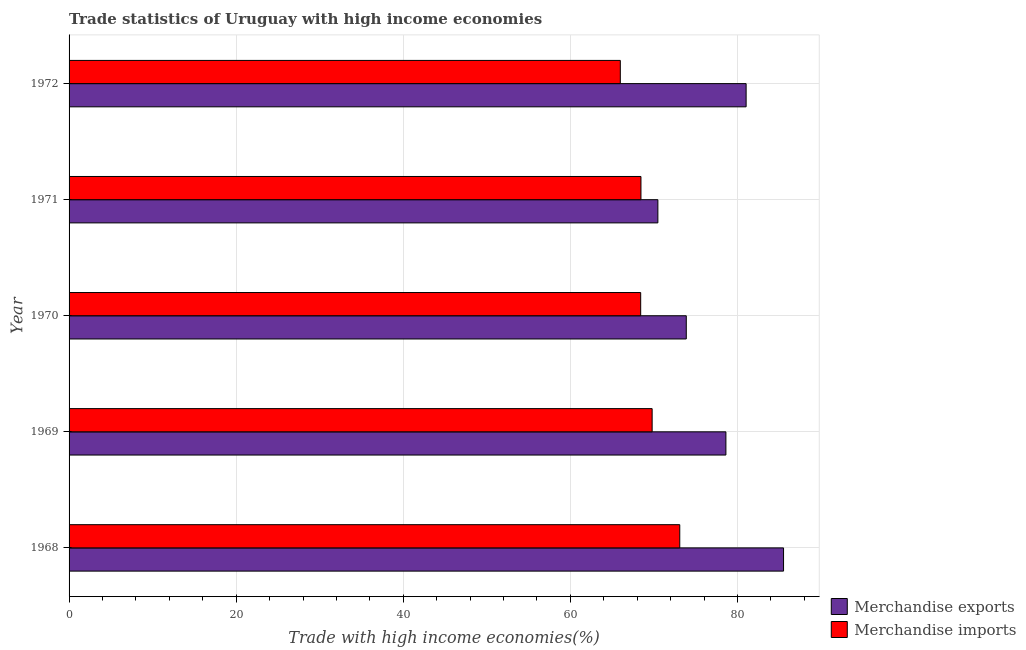How many different coloured bars are there?
Keep it short and to the point. 2. How many bars are there on the 4th tick from the top?
Your answer should be very brief. 2. In how many cases, is the number of bars for a given year not equal to the number of legend labels?
Provide a short and direct response. 0. What is the merchandise imports in 1968?
Provide a short and direct response. 73.09. Across all years, what is the maximum merchandise imports?
Offer a very short reply. 73.09. Across all years, what is the minimum merchandise exports?
Give a very brief answer. 70.47. In which year was the merchandise imports maximum?
Give a very brief answer. 1968. In which year was the merchandise imports minimum?
Your answer should be compact. 1972. What is the total merchandise imports in the graph?
Give a very brief answer. 345.71. What is the difference between the merchandise exports in 1971 and that in 1972?
Your answer should be compact. -10.56. What is the difference between the merchandise imports in 1971 and the merchandise exports in 1970?
Offer a very short reply. -5.42. What is the average merchandise imports per year?
Offer a very short reply. 69.14. In the year 1969, what is the difference between the merchandise exports and merchandise imports?
Make the answer very short. 8.83. What is the ratio of the merchandise imports in 1969 to that in 1971?
Keep it short and to the point. 1.02. Is the difference between the merchandise imports in 1968 and 1969 greater than the difference between the merchandise exports in 1968 and 1969?
Your answer should be very brief. No. What is the difference between the highest and the second highest merchandise exports?
Keep it short and to the point. 4.48. What is the difference between the highest and the lowest merchandise exports?
Offer a terse response. 15.04. What does the 1st bar from the top in 1969 represents?
Give a very brief answer. Merchandise imports. What does the 2nd bar from the bottom in 1968 represents?
Keep it short and to the point. Merchandise imports. How many bars are there?
Keep it short and to the point. 10. Are all the bars in the graph horizontal?
Ensure brevity in your answer.  Yes. What is the difference between two consecutive major ticks on the X-axis?
Offer a terse response. 20. Are the values on the major ticks of X-axis written in scientific E-notation?
Give a very brief answer. No. What is the title of the graph?
Ensure brevity in your answer.  Trade statistics of Uruguay with high income economies. What is the label or title of the X-axis?
Your answer should be compact. Trade with high income economies(%). What is the label or title of the Y-axis?
Give a very brief answer. Year. What is the Trade with high income economies(%) of Merchandise exports in 1968?
Make the answer very short. 85.51. What is the Trade with high income economies(%) of Merchandise imports in 1968?
Provide a short and direct response. 73.09. What is the Trade with high income economies(%) in Merchandise exports in 1969?
Provide a succinct answer. 78.61. What is the Trade with high income economies(%) of Merchandise imports in 1969?
Provide a succinct answer. 69.78. What is the Trade with high income economies(%) of Merchandise exports in 1970?
Keep it short and to the point. 73.87. What is the Trade with high income economies(%) of Merchandise imports in 1970?
Your answer should be compact. 68.41. What is the Trade with high income economies(%) of Merchandise exports in 1971?
Give a very brief answer. 70.47. What is the Trade with high income economies(%) in Merchandise imports in 1971?
Make the answer very short. 68.45. What is the Trade with high income economies(%) in Merchandise exports in 1972?
Your response must be concise. 81.03. What is the Trade with high income economies(%) in Merchandise imports in 1972?
Provide a succinct answer. 65.98. Across all years, what is the maximum Trade with high income economies(%) of Merchandise exports?
Provide a short and direct response. 85.51. Across all years, what is the maximum Trade with high income economies(%) in Merchandise imports?
Offer a terse response. 73.09. Across all years, what is the minimum Trade with high income economies(%) of Merchandise exports?
Offer a terse response. 70.47. Across all years, what is the minimum Trade with high income economies(%) in Merchandise imports?
Provide a short and direct response. 65.98. What is the total Trade with high income economies(%) of Merchandise exports in the graph?
Your response must be concise. 389.5. What is the total Trade with high income economies(%) of Merchandise imports in the graph?
Your response must be concise. 345.71. What is the difference between the Trade with high income economies(%) of Merchandise exports in 1968 and that in 1969?
Ensure brevity in your answer.  6.9. What is the difference between the Trade with high income economies(%) in Merchandise imports in 1968 and that in 1969?
Make the answer very short. 3.31. What is the difference between the Trade with high income economies(%) of Merchandise exports in 1968 and that in 1970?
Give a very brief answer. 11.64. What is the difference between the Trade with high income economies(%) in Merchandise imports in 1968 and that in 1970?
Your answer should be very brief. 4.68. What is the difference between the Trade with high income economies(%) of Merchandise exports in 1968 and that in 1971?
Ensure brevity in your answer.  15.04. What is the difference between the Trade with high income economies(%) of Merchandise imports in 1968 and that in 1971?
Keep it short and to the point. 4.64. What is the difference between the Trade with high income economies(%) of Merchandise exports in 1968 and that in 1972?
Ensure brevity in your answer.  4.48. What is the difference between the Trade with high income economies(%) in Merchandise imports in 1968 and that in 1972?
Your answer should be very brief. 7.12. What is the difference between the Trade with high income economies(%) of Merchandise exports in 1969 and that in 1970?
Give a very brief answer. 4.74. What is the difference between the Trade with high income economies(%) of Merchandise imports in 1969 and that in 1970?
Ensure brevity in your answer.  1.37. What is the difference between the Trade with high income economies(%) in Merchandise exports in 1969 and that in 1971?
Give a very brief answer. 8.14. What is the difference between the Trade with high income economies(%) in Merchandise imports in 1969 and that in 1971?
Offer a terse response. 1.34. What is the difference between the Trade with high income economies(%) in Merchandise exports in 1969 and that in 1972?
Offer a terse response. -2.42. What is the difference between the Trade with high income economies(%) in Merchandise imports in 1969 and that in 1972?
Ensure brevity in your answer.  3.81. What is the difference between the Trade with high income economies(%) in Merchandise exports in 1970 and that in 1971?
Keep it short and to the point. 3.4. What is the difference between the Trade with high income economies(%) of Merchandise imports in 1970 and that in 1971?
Your response must be concise. -0.03. What is the difference between the Trade with high income economies(%) of Merchandise exports in 1970 and that in 1972?
Offer a very short reply. -7.16. What is the difference between the Trade with high income economies(%) of Merchandise imports in 1970 and that in 1972?
Provide a short and direct response. 2.44. What is the difference between the Trade with high income economies(%) in Merchandise exports in 1971 and that in 1972?
Provide a short and direct response. -10.56. What is the difference between the Trade with high income economies(%) in Merchandise imports in 1971 and that in 1972?
Your answer should be very brief. 2.47. What is the difference between the Trade with high income economies(%) in Merchandise exports in 1968 and the Trade with high income economies(%) in Merchandise imports in 1969?
Make the answer very short. 15.73. What is the difference between the Trade with high income economies(%) in Merchandise exports in 1968 and the Trade with high income economies(%) in Merchandise imports in 1970?
Ensure brevity in your answer.  17.1. What is the difference between the Trade with high income economies(%) in Merchandise exports in 1968 and the Trade with high income economies(%) in Merchandise imports in 1971?
Give a very brief answer. 17.07. What is the difference between the Trade with high income economies(%) in Merchandise exports in 1968 and the Trade with high income economies(%) in Merchandise imports in 1972?
Ensure brevity in your answer.  19.54. What is the difference between the Trade with high income economies(%) in Merchandise exports in 1969 and the Trade with high income economies(%) in Merchandise imports in 1970?
Offer a terse response. 10.2. What is the difference between the Trade with high income economies(%) in Merchandise exports in 1969 and the Trade with high income economies(%) in Merchandise imports in 1971?
Your answer should be very brief. 10.17. What is the difference between the Trade with high income economies(%) in Merchandise exports in 1969 and the Trade with high income economies(%) in Merchandise imports in 1972?
Keep it short and to the point. 12.64. What is the difference between the Trade with high income economies(%) in Merchandise exports in 1970 and the Trade with high income economies(%) in Merchandise imports in 1971?
Your answer should be compact. 5.42. What is the difference between the Trade with high income economies(%) of Merchandise exports in 1970 and the Trade with high income economies(%) of Merchandise imports in 1972?
Your answer should be very brief. 7.9. What is the difference between the Trade with high income economies(%) in Merchandise exports in 1971 and the Trade with high income economies(%) in Merchandise imports in 1972?
Ensure brevity in your answer.  4.49. What is the average Trade with high income economies(%) in Merchandise exports per year?
Make the answer very short. 77.9. What is the average Trade with high income economies(%) of Merchandise imports per year?
Provide a short and direct response. 69.14. In the year 1968, what is the difference between the Trade with high income economies(%) of Merchandise exports and Trade with high income economies(%) of Merchandise imports?
Ensure brevity in your answer.  12.42. In the year 1969, what is the difference between the Trade with high income economies(%) in Merchandise exports and Trade with high income economies(%) in Merchandise imports?
Ensure brevity in your answer.  8.83. In the year 1970, what is the difference between the Trade with high income economies(%) of Merchandise exports and Trade with high income economies(%) of Merchandise imports?
Offer a terse response. 5.46. In the year 1971, what is the difference between the Trade with high income economies(%) of Merchandise exports and Trade with high income economies(%) of Merchandise imports?
Your response must be concise. 2.02. In the year 1972, what is the difference between the Trade with high income economies(%) of Merchandise exports and Trade with high income economies(%) of Merchandise imports?
Provide a short and direct response. 15.06. What is the ratio of the Trade with high income economies(%) in Merchandise exports in 1968 to that in 1969?
Offer a very short reply. 1.09. What is the ratio of the Trade with high income economies(%) in Merchandise imports in 1968 to that in 1969?
Offer a terse response. 1.05. What is the ratio of the Trade with high income economies(%) in Merchandise exports in 1968 to that in 1970?
Make the answer very short. 1.16. What is the ratio of the Trade with high income economies(%) in Merchandise imports in 1968 to that in 1970?
Offer a terse response. 1.07. What is the ratio of the Trade with high income economies(%) in Merchandise exports in 1968 to that in 1971?
Offer a very short reply. 1.21. What is the ratio of the Trade with high income economies(%) of Merchandise imports in 1968 to that in 1971?
Your answer should be very brief. 1.07. What is the ratio of the Trade with high income economies(%) in Merchandise exports in 1968 to that in 1972?
Offer a terse response. 1.06. What is the ratio of the Trade with high income economies(%) in Merchandise imports in 1968 to that in 1972?
Your answer should be compact. 1.11. What is the ratio of the Trade with high income economies(%) in Merchandise exports in 1969 to that in 1970?
Ensure brevity in your answer.  1.06. What is the ratio of the Trade with high income economies(%) of Merchandise exports in 1969 to that in 1971?
Provide a short and direct response. 1.12. What is the ratio of the Trade with high income economies(%) of Merchandise imports in 1969 to that in 1971?
Keep it short and to the point. 1.02. What is the ratio of the Trade with high income economies(%) of Merchandise exports in 1969 to that in 1972?
Make the answer very short. 0.97. What is the ratio of the Trade with high income economies(%) in Merchandise imports in 1969 to that in 1972?
Offer a very short reply. 1.06. What is the ratio of the Trade with high income economies(%) in Merchandise exports in 1970 to that in 1971?
Your answer should be very brief. 1.05. What is the ratio of the Trade with high income economies(%) in Merchandise exports in 1970 to that in 1972?
Your answer should be very brief. 0.91. What is the ratio of the Trade with high income economies(%) of Merchandise exports in 1971 to that in 1972?
Ensure brevity in your answer.  0.87. What is the ratio of the Trade with high income economies(%) in Merchandise imports in 1971 to that in 1972?
Keep it short and to the point. 1.04. What is the difference between the highest and the second highest Trade with high income economies(%) in Merchandise exports?
Offer a very short reply. 4.48. What is the difference between the highest and the second highest Trade with high income economies(%) of Merchandise imports?
Your answer should be very brief. 3.31. What is the difference between the highest and the lowest Trade with high income economies(%) in Merchandise exports?
Provide a succinct answer. 15.04. What is the difference between the highest and the lowest Trade with high income economies(%) of Merchandise imports?
Keep it short and to the point. 7.12. 